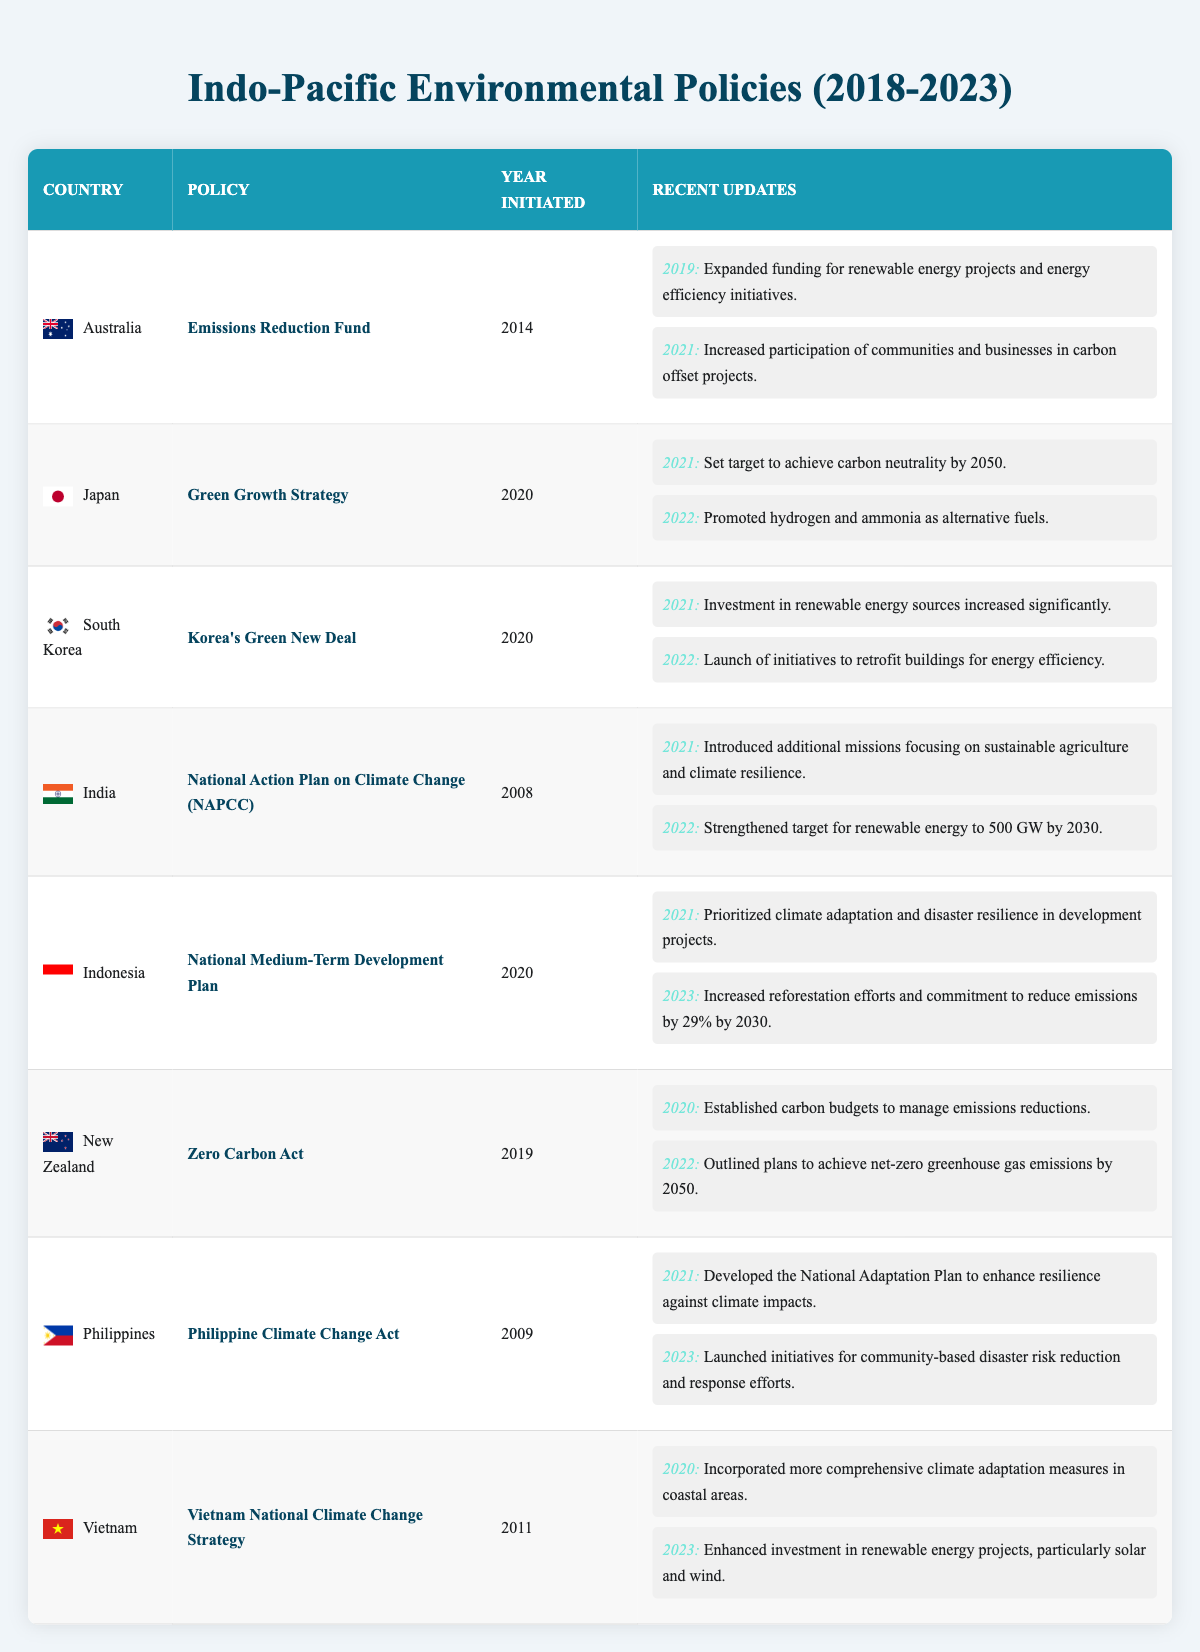What is the most recent update for Indonesia's National Medium-Term Development Plan? According to the table, the most recent update for Indonesia's National Medium-Term Development Plan occurred in 2023, where it mentions the increased reforestation efforts and a commitment to reduce emissions by 29% by 2030.
Answer: Increased reforestation efforts and a commitment to reduce emissions by 29% by 2030 Which country has a policy initiated in 2014? Upon reviewing the table, Australia has a policy called the Emissions Reduction Fund that was initiated in 2014.
Answer: Australia Have any countries updated their policies to involve community participation? Yes, both Australia and the Philippines mentioned updates that involve community activities; Australia increased participation of communities and businesses in carbon offset projects in 2021, and the Philippines launched initiatives for community-based disaster risk reduction and response efforts in 2023.
Answer: Yes What was the target set by Japan in 2021 regarding carbon neutrality? The table indicates that Japan set a target to achieve carbon neutrality by 2050 in 2021, which is an essential aspect of its Green Growth Strategy.
Answer: Achieve carbon neutrality by 2050 How many countries initiated their environmental policy after 2020? By examining the table, four countries initiated their policies after 2020: Japan (Green Growth Strategy), South Korea (Korea's Green New Deal), Indonesia (National Medium-Term Development Plan), and New Zealand (Zero Carbon Act). Therefore, the total is four.
Answer: Four Which policy aims for net-zero greenhouse gas emissions by 2050? Based on the table, New Zealand's Zero Carbon Act outlines plans to achieve net-zero greenhouse gas emissions by 2050.
Answer: Zero Carbon Act Did Australia include any updates in 2021? Yes, Australia has included an update in 2021 regarding its Emissions Reduction Fund, which emphasized increased participation of communities and businesses in carbon offset projects.
Answer: Yes Which country focuses on both sustainable agriculture and climate resilience as part of its climate policy updates? According to the table, India introduced additional missions focusing on sustainable agriculture and climate resilience as part of its National Action Plan on Climate Change in 2021.
Answer: India 